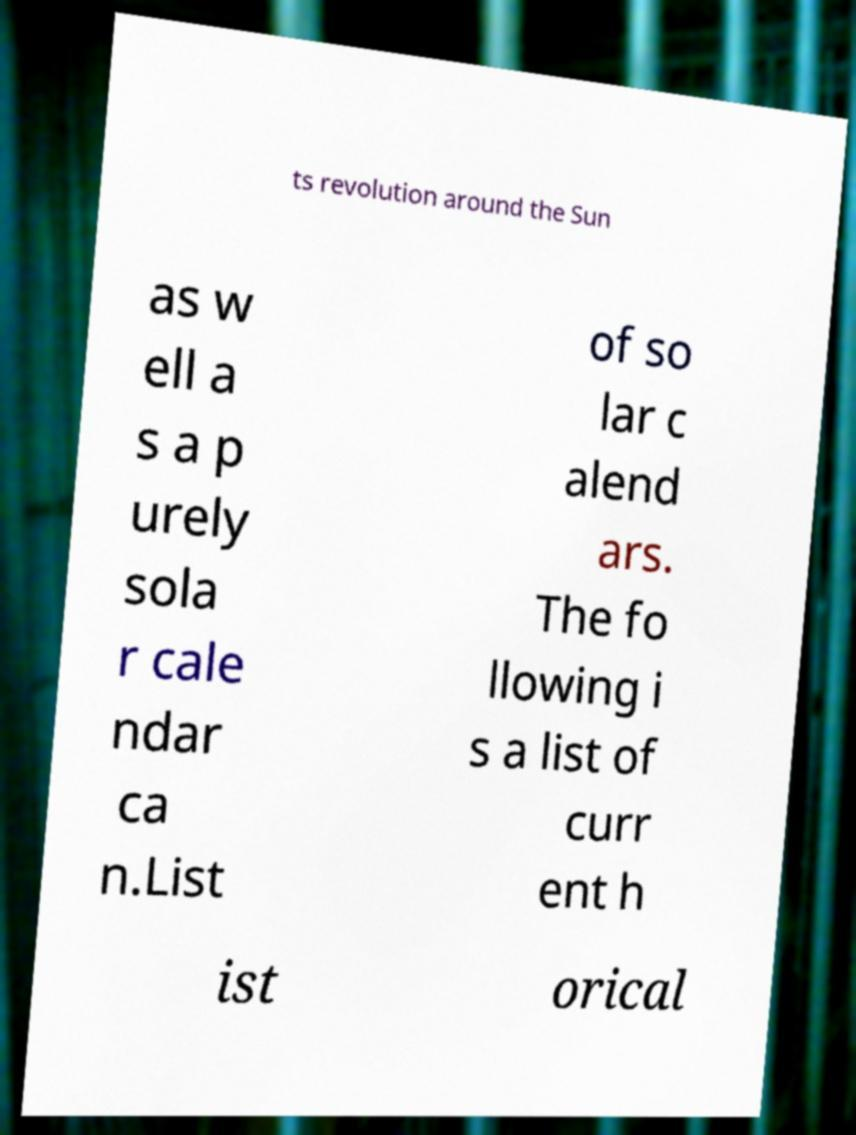Could you extract and type out the text from this image? ts revolution around the Sun as w ell a s a p urely sola r cale ndar ca n.List of so lar c alend ars. The fo llowing i s a list of curr ent h ist orical 